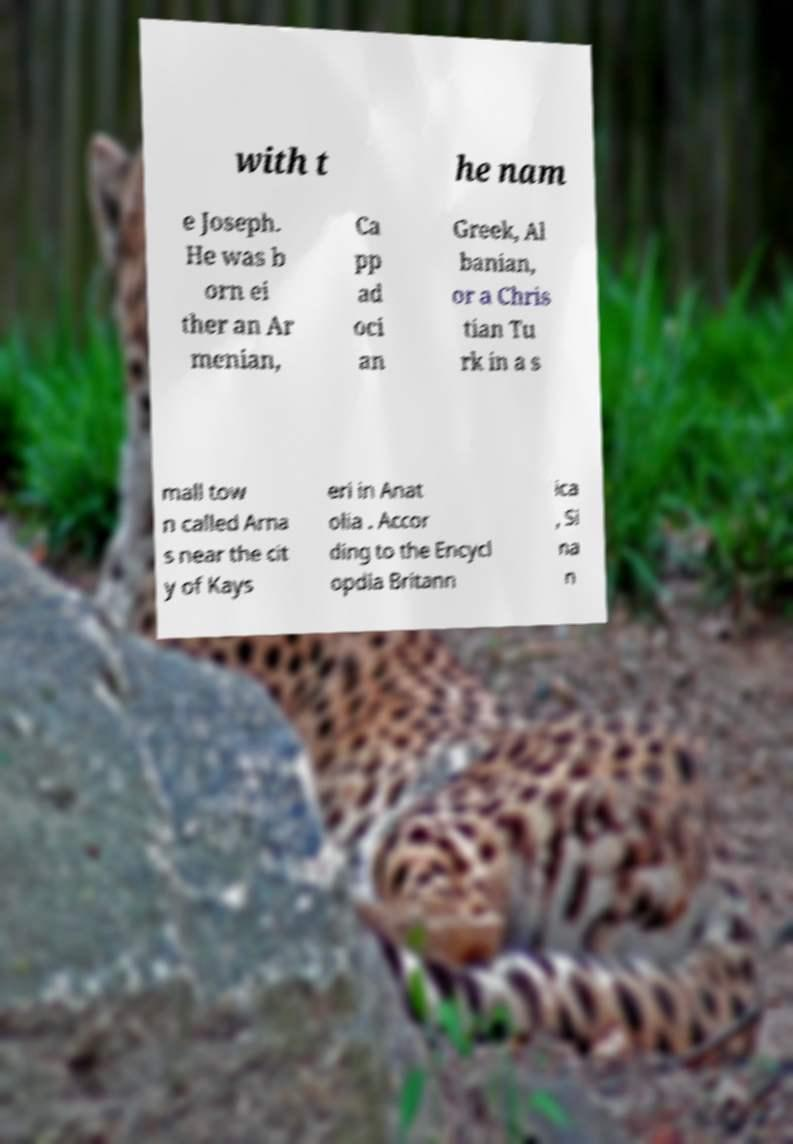I need the written content from this picture converted into text. Can you do that? with t he nam e Joseph. He was b orn ei ther an Ar menian, Ca pp ad oci an Greek, Al banian, or a Chris tian Tu rk in a s mall tow n called Arna s near the cit y of Kays eri in Anat olia . Accor ding to the Encycl opdia Britann ica , Si na n 